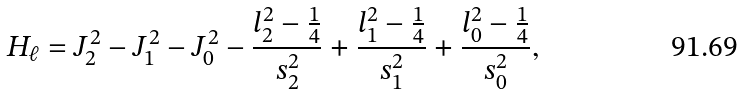<formula> <loc_0><loc_0><loc_500><loc_500>H _ { \ell } = J _ { 2 } ^ { 2 } - J _ { 1 } ^ { 2 } - J _ { 0 } ^ { 2 } - \frac { l _ { 2 } ^ { 2 } - \frac { 1 } { 4 } } { s _ { 2 } ^ { 2 } } + \frac { l _ { 1 } ^ { 2 } - \frac { 1 } { 4 } } { s _ { 1 } ^ { 2 } } + \frac { l _ { 0 } ^ { 2 } - \frac { 1 } { 4 } } { s _ { 0 } ^ { 2 } } ,</formula> 